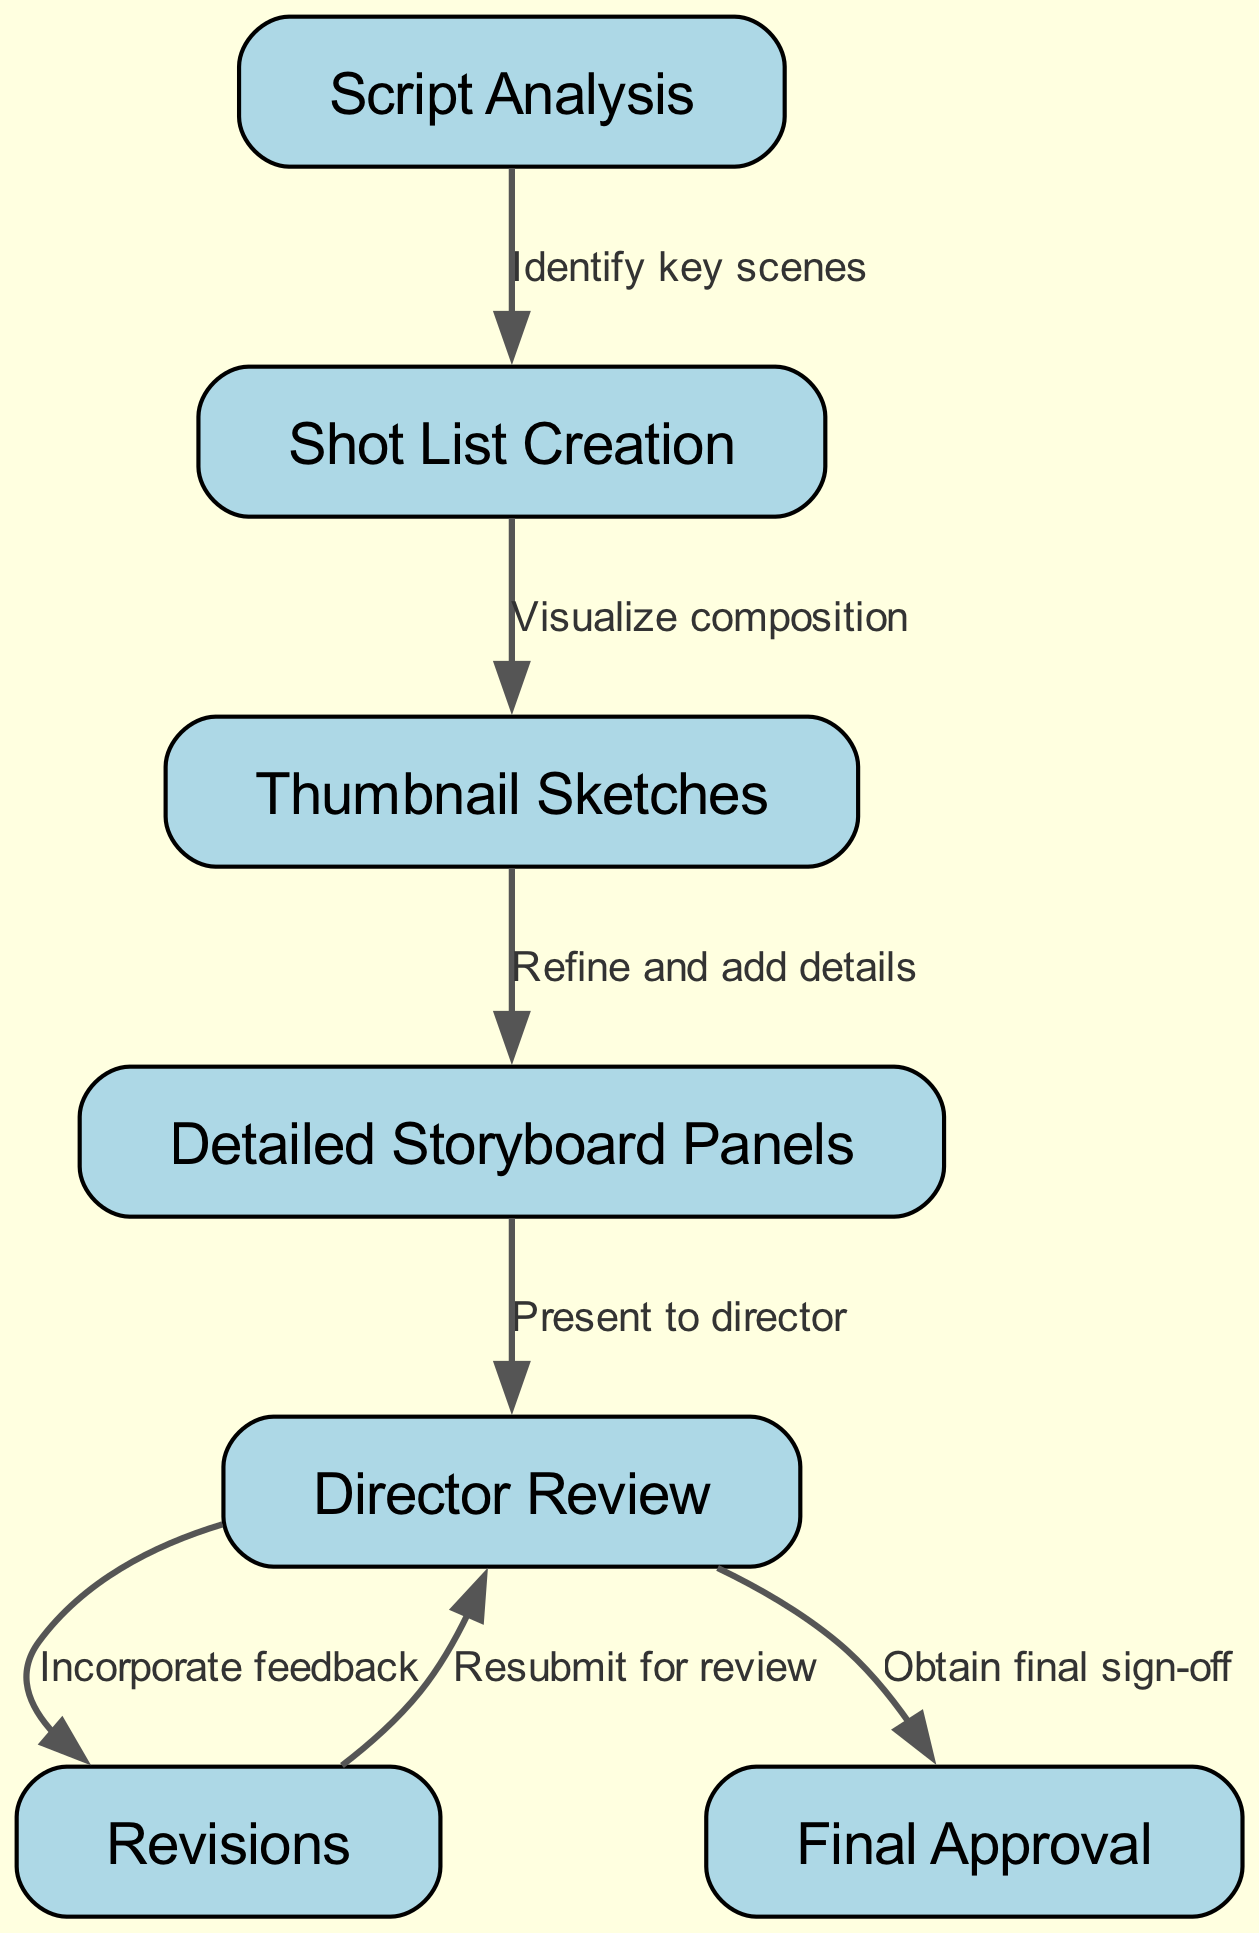What is the first step in the storyboard creation process? The flowchart indicates that the first step is "Script Analysis," which is the initial task before any other steps can take place.
Answer: Script Analysis How many total nodes are there in the diagram? By counting the nodes provided in the data, there are a total of 7 nodes in the diagram representing different steps in the storyboard creation process.
Answer: 7 What is the final step before obtaining final approval? According to the flowchart, the step prior to "Final Approval" is "Director Review," outlining the process of seeking feedback from the director.
Answer: Director Review Which step follows "Thumbnail Sketches"? The diagram shows that after "Thumbnail Sketches," the next step is "Detailed Storyboard Panels," where the artist refines the initial sketches into more detailed panels.
Answer: Detailed Storyboard Panels What feedback process occurs after the director review? The flowchart specifies that after the "Director Review," there are "Revisions" based on the director's feedback, indicating an iterative process of refinement.
Answer: Revisions How many edges are present in the diagram? By looking at the connections represented as edges in the flowchart, there are a total of 6 edges that show the relationships between the various nodes of the storyboard creation process.
Answer: 6 What connects "Detailed Storyboard Panels" to "Director Review"? The edge connecting these two nodes is represented by "Present to director," indicating the action taken during the storyboard presentation phase.
Answer: Present to director Which node is reached after incorporating feedback? The flowchart indicates that after the "Revisions," the process returns to "Director Review," where the artist resubmits the revised storyboard for further evaluation.
Answer: Director Review What is the relationship between "Shot List Creation" and "Thumbnail Sketches"? The flowchart establishes a directional relationship indicating that "Shot List Creation" leads to "Thumbnail Sketches," framed as "Visualize composition."
Answer: Visualize composition 